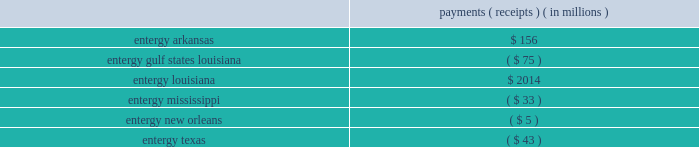Entergy corporation and subsidiaries notes to financial statements equitable discretion and not require refunds for the 20-month period from september 13 , 2001 - may 2 , 2003 .
Because the ruling on refunds relied on findings in the interruptible load proceeding , which is discussed in a separate section below , the ferc concluded that the refund ruling will be held in abeyance pending the outcome of the rehearing requests in that proceeding .
On the second issue , the ferc reversed its prior decision and ordered that the prospective bandwidth remedy begin on june 1 , 2005 ( the date of its initial order in the proceeding ) rather than january 1 , 2006 , as it had previously ordered .
Pursuant to the october 2011 order , entergy was required to calculate the additional bandwidth payments for the period june - december 2005 utilizing the bandwidth formula tariff prescribed by the ferc that was filed in a december 2006 compliance filing and accepted by the ferc in an april 2007 order .
As is the case with bandwidth remedy payments , these payments and receipts will ultimately be paid by utility operating company customers to other utility operating company customers .
In december 2011 , entergy filed with the ferc its compliance filing that provides the payments and receipts among the utility operating companies pursuant to the ferc 2019s october 2011 order .
The filing shows the following payments/receipts among the utility operating companies : payments ( receipts ) ( in millions ) .
Entergy arkansas made its payment in january 2012 .
In february 2012 , entergy arkansas filed for an interim adjustment to its production cost allocation rider requesting that the $ 156 million payment be collected from customers over the 22-month period from march 2012 through december 2013 .
In march 2012 the apsc issued an order stating that the payment can be recovered from retail customers through the production cost allocation rider , subject to refund .
The lpsc and the apsc have requested rehearing of the ferc 2019s october 2011 order .
In december 2013 the lpsc filed a petition for a writ of mandamus at the united states court of appeals for the d.c .
Circuit .
In its petition , the lpsc requested that the d.c .
Circuit issue an order compelling the ferc to issue a final order on pending rehearing requests .
In its response to the lpsc petition , the ferc committed to rule on the pending rehearing request before the end of february .
In january 2014 the d.c .
Circuit denied the lpsc's petition .
The apsc , the lpsc , the puct , and other parties intervened in the december 2011 compliance filing proceeding , and the apsc and the lpsc also filed protests .
Calendar year 2013 production costs the liabilities and assets for the preliminary estimate of the payments and receipts required to implement the ferc 2019s remedy based on calendar year 2013 production costs were recorded in december 2013 , based on certain year-to-date information .
The preliminary estimate was recorded based on the following estimate of the payments/receipts among the utility operating companies for 2014. .
What portion of the entergy arkansas payment goes to entergy texas? 
Computations: (43 / 156)
Answer: 0.27564. 